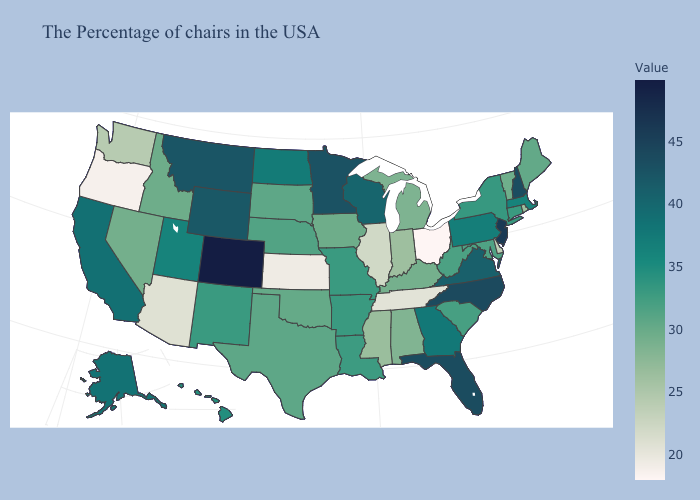Does South Carolina have a lower value than Kansas?
Keep it brief. No. Does West Virginia have the highest value in the USA?
Be succinct. No. Which states hav the highest value in the Northeast?
Short answer required. New Jersey. Among the states that border Washington , which have the lowest value?
Keep it brief. Oregon. Is the legend a continuous bar?
Be succinct. Yes. Which states have the lowest value in the Northeast?
Answer briefly. Rhode Island. Does Arkansas have the lowest value in the South?
Answer briefly. No. Which states have the highest value in the USA?
Keep it brief. Colorado. 